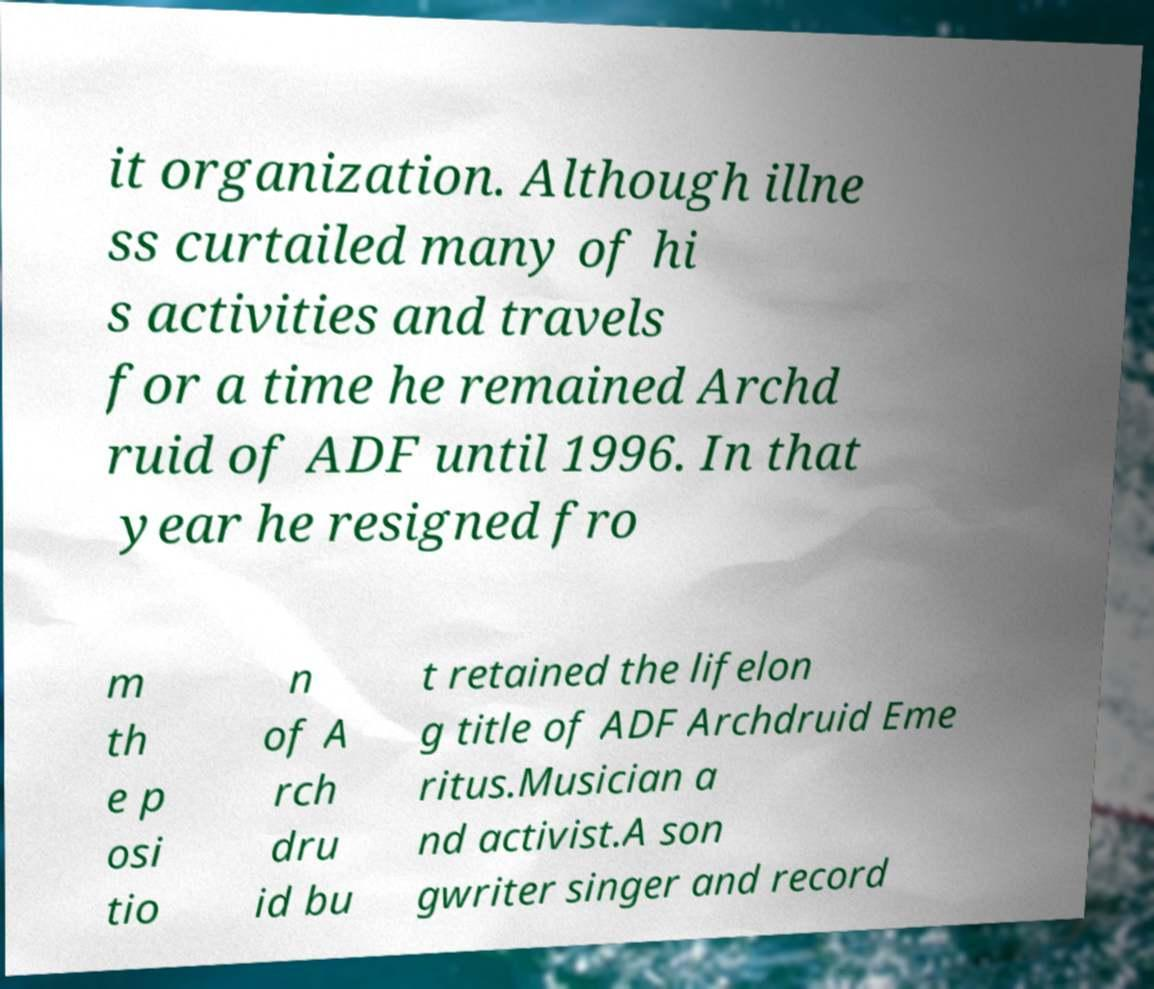What messages or text are displayed in this image? I need them in a readable, typed format. it organization. Although illne ss curtailed many of hi s activities and travels for a time he remained Archd ruid of ADF until 1996. In that year he resigned fro m th e p osi tio n of A rch dru id bu t retained the lifelon g title of ADF Archdruid Eme ritus.Musician a nd activist.A son gwriter singer and record 